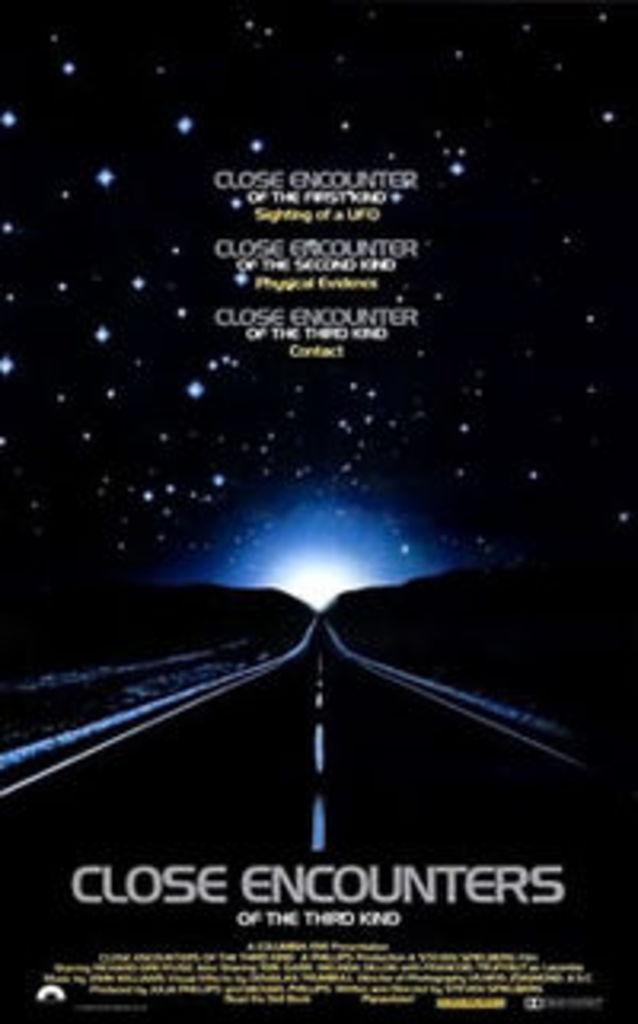<image>
Summarize the visual content of the image. A movie poster for the 1970's classic movie "Close Encounters of the Third Kind". 